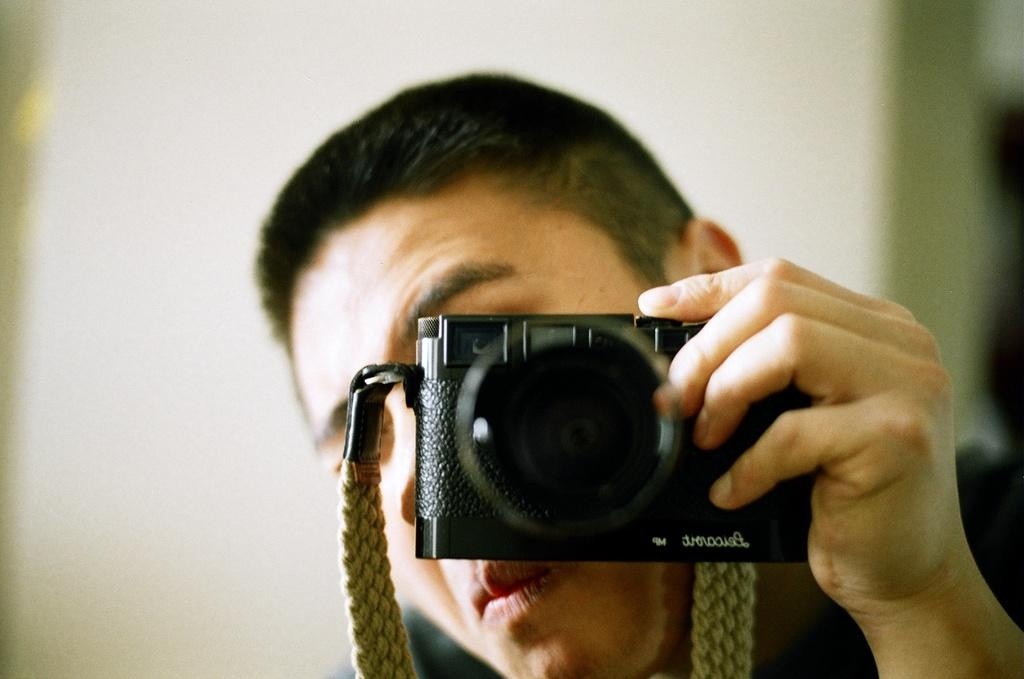What is the main subject of the image? There is a person in the image. What is the person holding in their hand? The person is holding a camera with their hand. What feature is present on the camera to help secure it? The camera has a strap. What can be seen in the background of the image? There is a wall in the background of the image. How many eyes can be seen on the camera in the image? There are no eyes visible on the camera in the image, as cameras do not have eyes. 